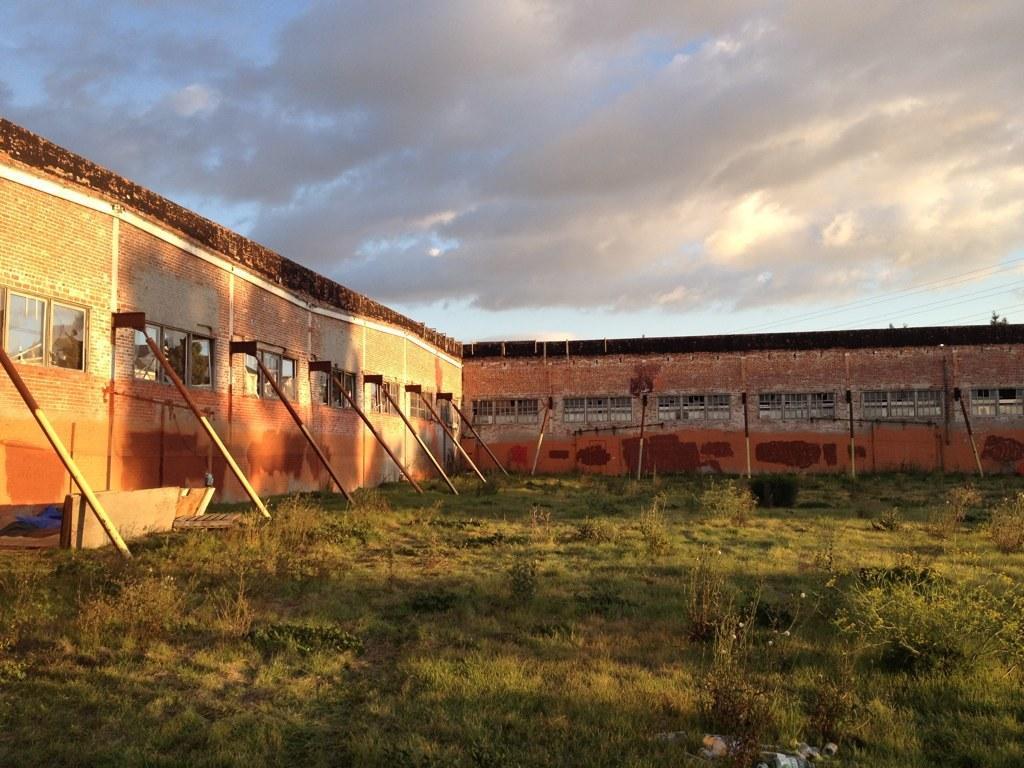Please provide a concise description of this image. In this image I can see a building with windows in the center of the image. I can see some poles coming out of the brick wall of the building. I can see some green garden at the bottom of the image with grass. At the top of the image I can see the sky. 